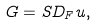<formula> <loc_0><loc_0><loc_500><loc_500>G = S D _ { F } u ,</formula> 